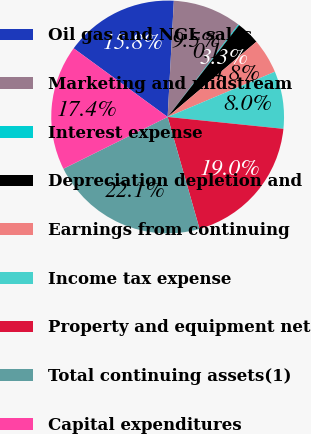Convert chart to OTSL. <chart><loc_0><loc_0><loc_500><loc_500><pie_chart><fcel>Oil gas and NGL sales<fcel>Marketing and midstream<fcel>Interest expense<fcel>Depreciation depletion and<fcel>Earnings from continuing<fcel>Income tax expense<fcel>Property and equipment net<fcel>Total continuing assets(1)<fcel>Capital expenditures<nl><fcel>15.81%<fcel>9.54%<fcel>0.14%<fcel>3.28%<fcel>4.84%<fcel>7.98%<fcel>18.95%<fcel>22.08%<fcel>17.38%<nl></chart> 